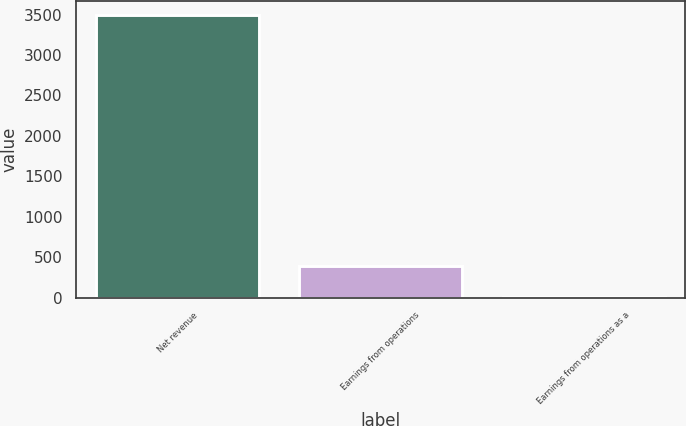Convert chart. <chart><loc_0><loc_0><loc_500><loc_500><bar_chart><fcel>Net revenue<fcel>Earnings from operations<fcel>Earnings from operations as a<nl><fcel>3498<fcel>389<fcel>11.1<nl></chart> 